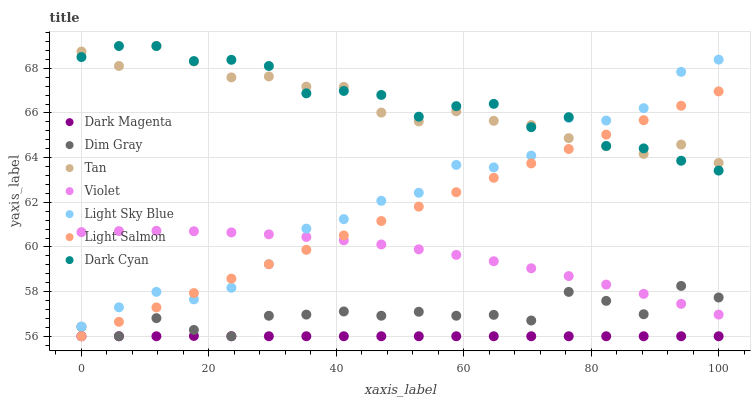Does Dark Magenta have the minimum area under the curve?
Answer yes or no. Yes. Does Dark Cyan have the maximum area under the curve?
Answer yes or no. Yes. Does Dim Gray have the minimum area under the curve?
Answer yes or no. No. Does Dim Gray have the maximum area under the curve?
Answer yes or no. No. Is Light Salmon the smoothest?
Answer yes or no. Yes. Is Light Sky Blue the roughest?
Answer yes or no. Yes. Is Dim Gray the smoothest?
Answer yes or no. No. Is Dim Gray the roughest?
Answer yes or no. No. Does Light Salmon have the lowest value?
Answer yes or no. Yes. Does Light Sky Blue have the lowest value?
Answer yes or no. No. Does Tan have the highest value?
Answer yes or no. Yes. Does Dim Gray have the highest value?
Answer yes or no. No. Is Dim Gray less than Tan?
Answer yes or no. Yes. Is Light Sky Blue greater than Dim Gray?
Answer yes or no. Yes. Does Tan intersect Light Salmon?
Answer yes or no. Yes. Is Tan less than Light Salmon?
Answer yes or no. No. Is Tan greater than Light Salmon?
Answer yes or no. No. Does Dim Gray intersect Tan?
Answer yes or no. No. 